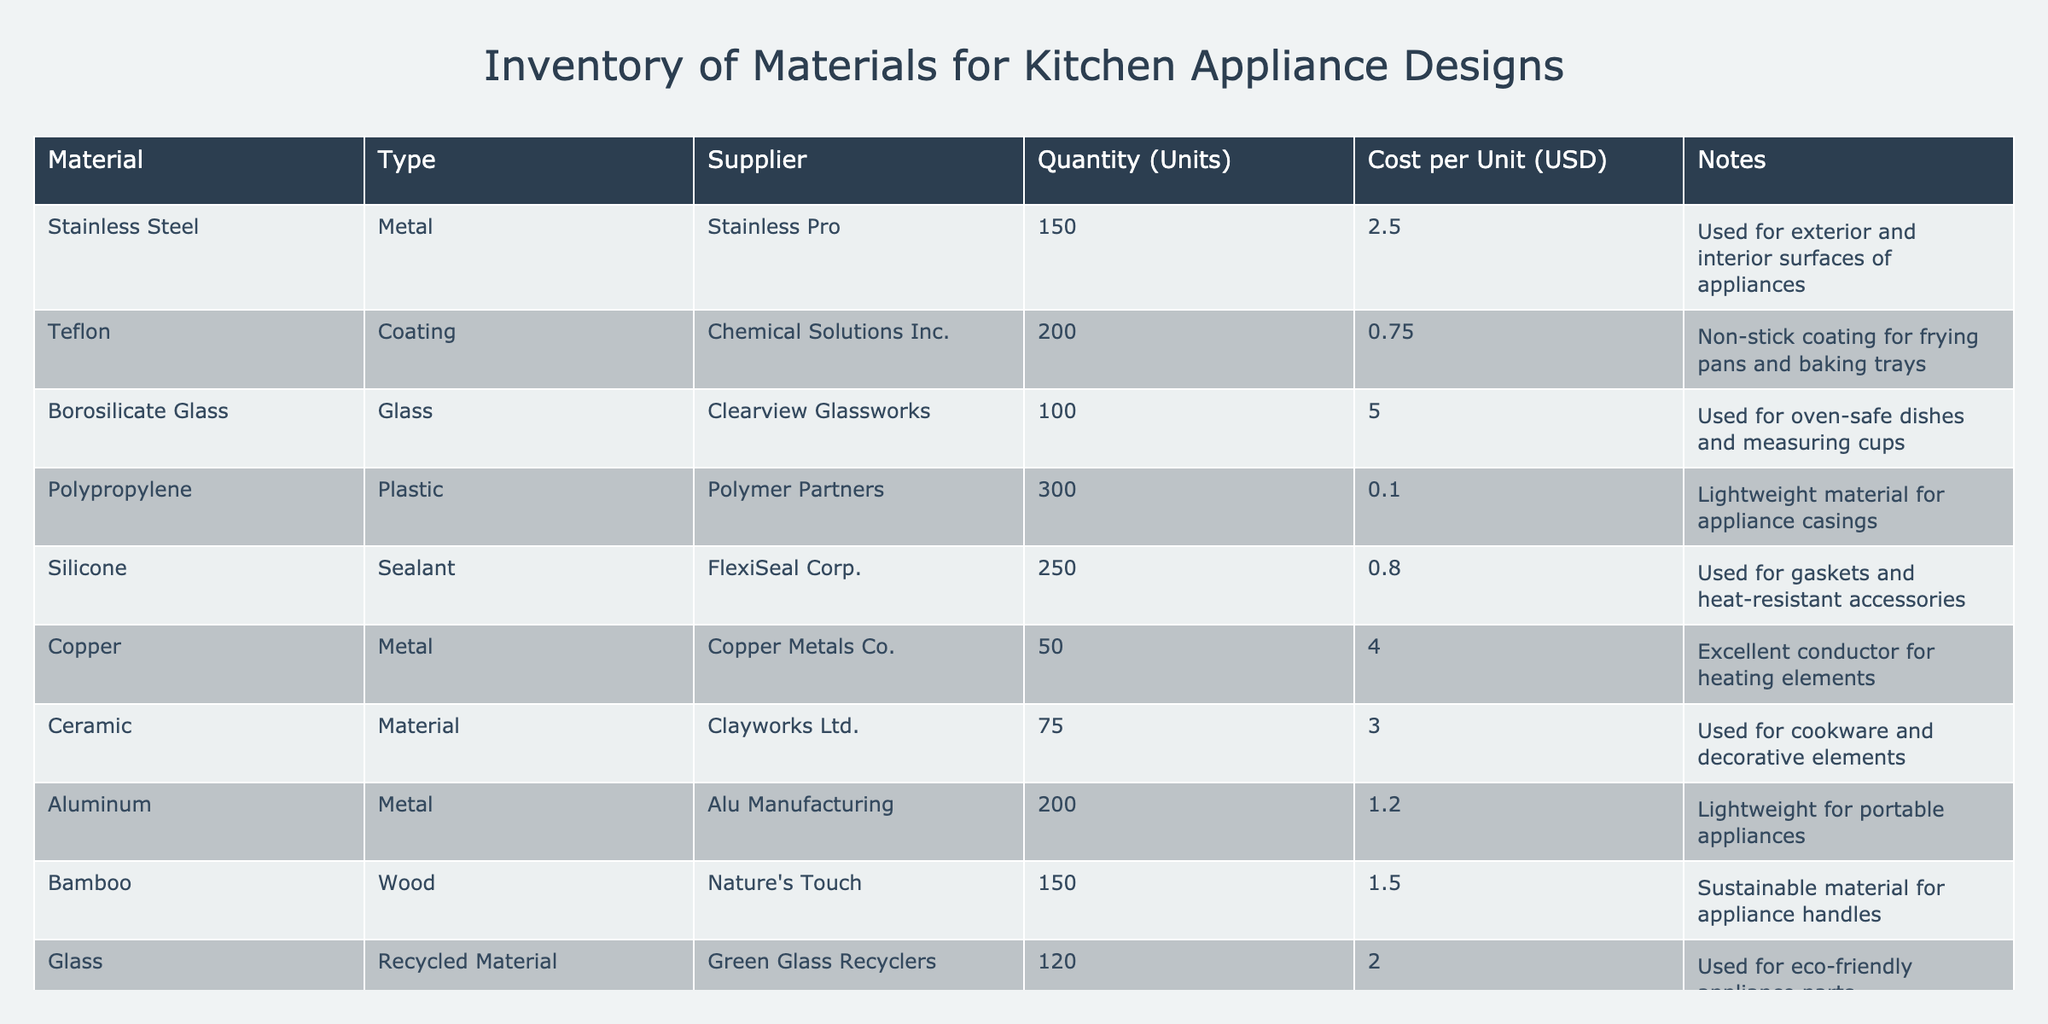What is the total quantity of Aluminum available in the inventory? The quantity of Aluminum listed in the table is 200 units. Therefore, the total quantity of Aluminum is 200 units.
Answer: 200 Which material has the highest cost per unit? The materials are listed with their respective costs. Comparing the costs, Borosilicate Glass costs 5.00 USD per unit, which is higher than all other materials.
Answer: Borosilicate Glass Is there a material listed that has a quantity greater than 250 units? The table lists the quantities of each material. Looking through the quantities, only Polypropylene has a quantity of 300 units, which is greater than 250 units.
Answer: Yes What is the average cost per unit of the plastic materials listed in the inventory? The plastic materials in the table are Polypropylene (0.10 USD) and Silicone (0.80 USD). To find the average, we sum these costs (0.10 + 0.80 = 0.90) and divide by the count of plastic materials (2), which gives an average of 0.90/2 = 0.45 USD.
Answer: 0.45 Are all metal materials sourced from different suppliers? The metals listed are Stainless Steel from Stainless Pro, Copper from Copper Metals Co., and Aluminum from Alu Manufacturing. Since each metal comes from a different supplier, the answer is yes.
Answer: Yes How much total quantity of materials comes from suppliers with the term "Corp" in their name? The materials from suppliers with “Corp” in the name are Silicone (250 units from FlexiSeal Corp) and Teflon (200 units from Chemical Solutions Inc.). Adding these quantities together gives 250 + 200 = 450 units.
Answer: 450 Which material used for coatings is listed in the inventory and how many units are available? The coating material listed in the inventory is Teflon, and it has a quantity of 200 units.
Answer: Teflon, 200 What is the total cost of materials derived from wood? The only wood material provided is Bamboo, which costs 1.50 USD per unit and has a quantity of 150 units. The total cost is calculated as 150 units * 1.50 USD = 225 USD.
Answer: 225 Is there a material in the inventory that can be classified as eco-friendly? Yes, Glass is listed as a recycled material sourced from Green Glass Recyclers, which qualifies it as eco-friendly.
Answer: Yes 